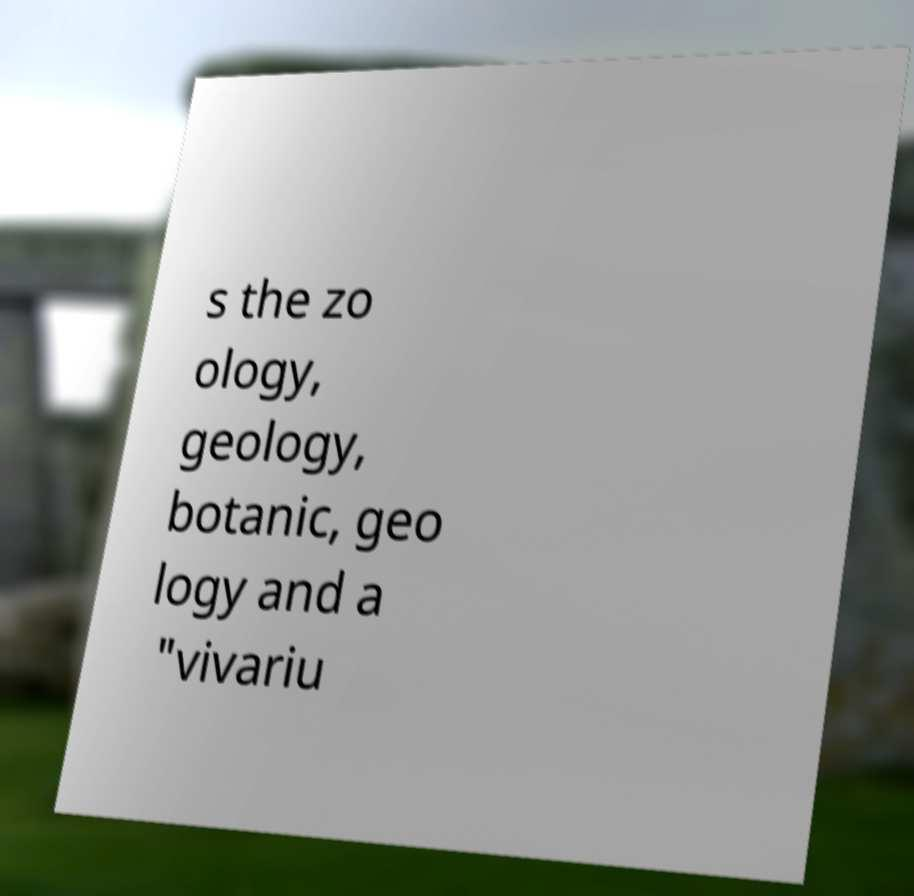Could you extract and type out the text from this image? s the zo ology, geology, botanic, geo logy and a "vivariu 